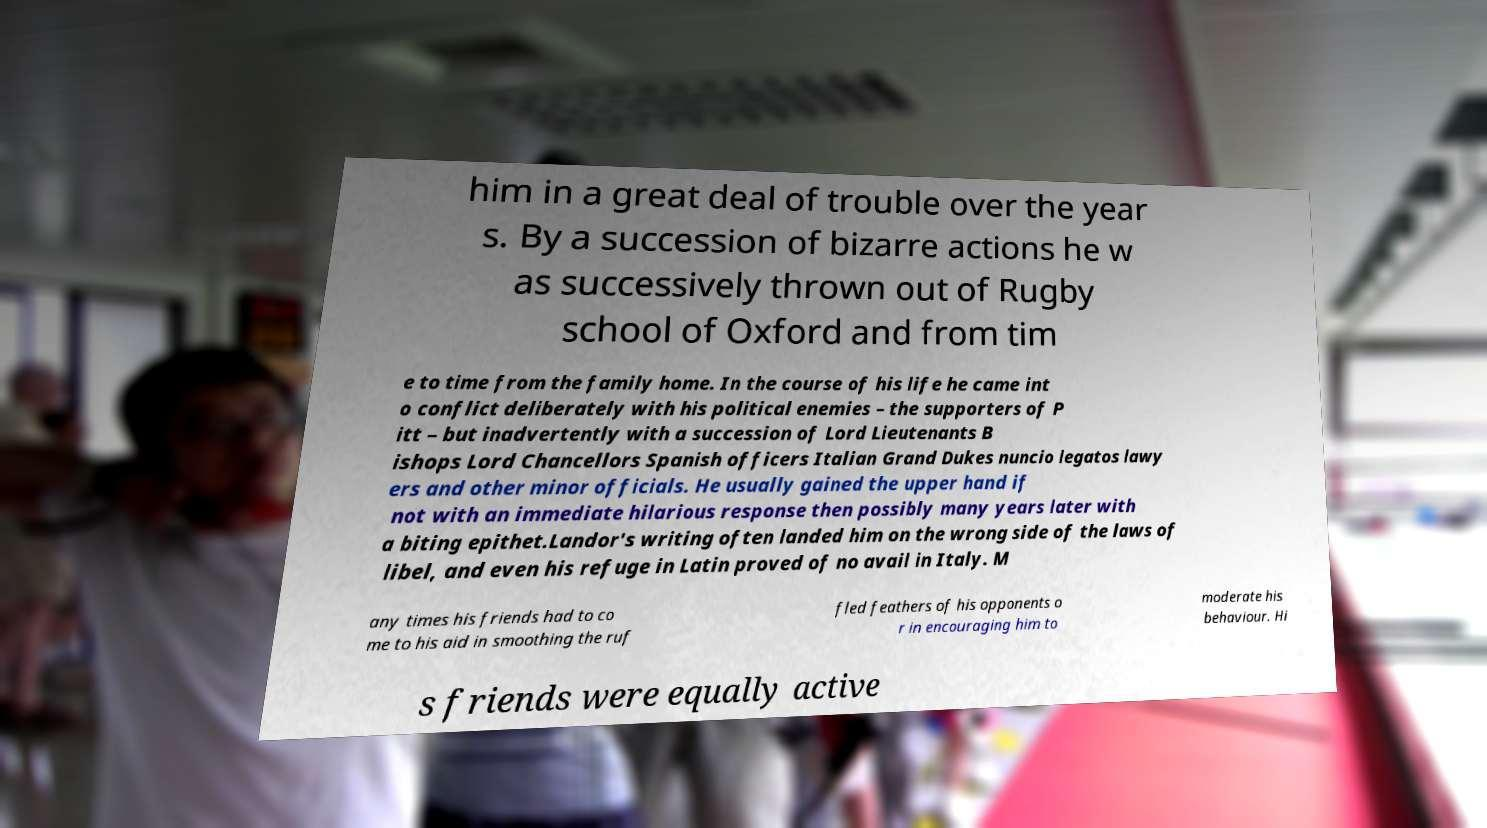There's text embedded in this image that I need extracted. Can you transcribe it verbatim? him in a great deal of trouble over the year s. By a succession of bizarre actions he w as successively thrown out of Rugby school of Oxford and from tim e to time from the family home. In the course of his life he came int o conflict deliberately with his political enemies – the supporters of P itt – but inadvertently with a succession of Lord Lieutenants B ishops Lord Chancellors Spanish officers Italian Grand Dukes nuncio legatos lawy ers and other minor officials. He usually gained the upper hand if not with an immediate hilarious response then possibly many years later with a biting epithet.Landor's writing often landed him on the wrong side of the laws of libel, and even his refuge in Latin proved of no avail in Italy. M any times his friends had to co me to his aid in smoothing the ruf fled feathers of his opponents o r in encouraging him to moderate his behaviour. Hi s friends were equally active 